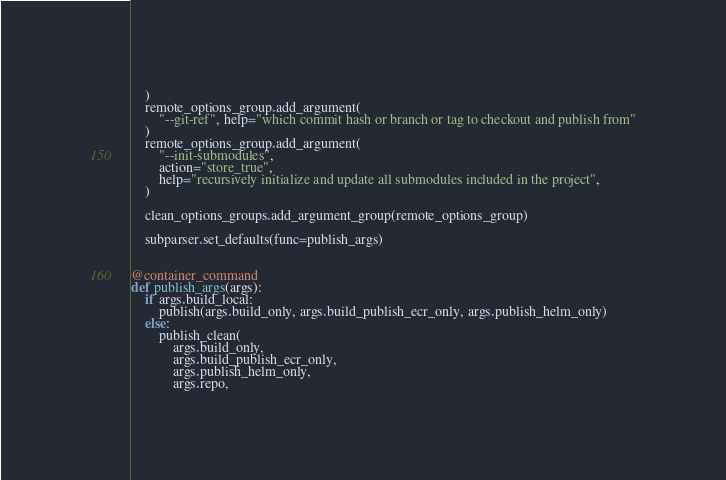<code> <loc_0><loc_0><loc_500><loc_500><_Python_>    )
    remote_options_group.add_argument(
        "--git-ref", help="which commit hash or branch or tag to checkout and publish from"
    )
    remote_options_group.add_argument(
        "--init-submodules",
        action="store_true",
        help="recursively initialize and update all submodules included in the project",
    )

    clean_options_groups.add_argument_group(remote_options_group)

    subparser.set_defaults(func=publish_args)


@container_command
def publish_args(args):
    if args.build_local:
        publish(args.build_only, args.build_publish_ecr_only, args.publish_helm_only)
    else:
        publish_clean(
            args.build_only,
            args.build_publish_ecr_only,
            args.publish_helm_only,
            args.repo,</code> 